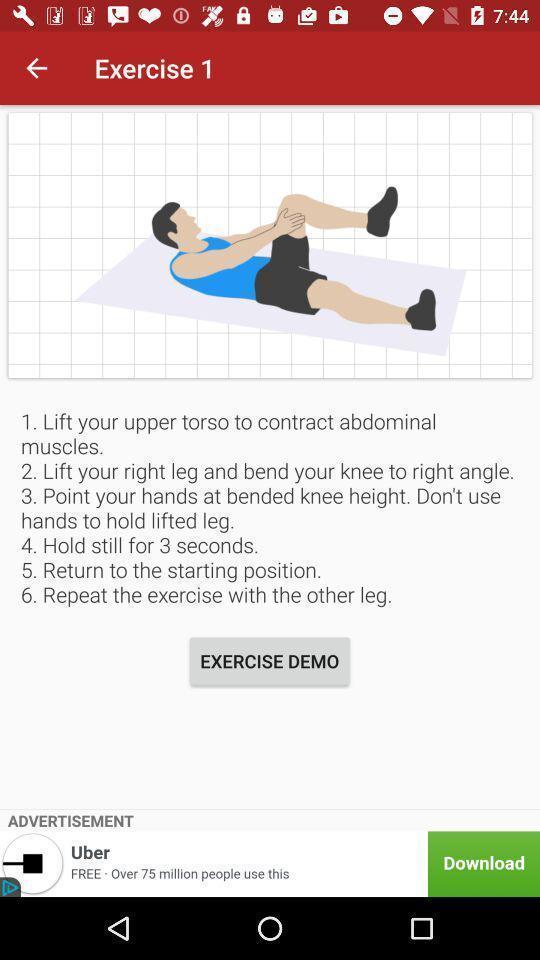Please provide a description for this image. Page that displaying fitness application. 